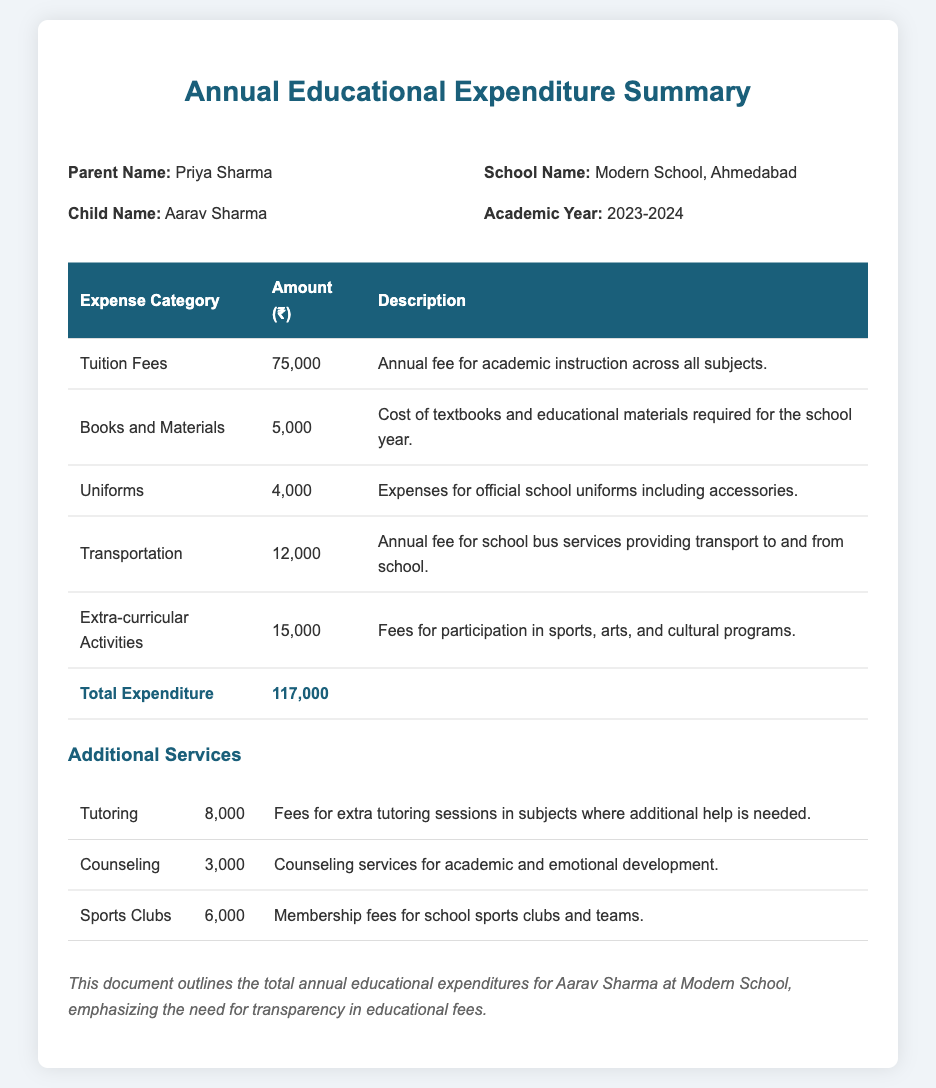What is the total tuition fee? The document specifies that the tuition fee for the academic year is ₹75,000.
Answer: ₹75,000 What is the amount spent on uniforms? The expenditure summary lists the cost for uniforms as ₹4,000.
Answer: ₹4,000 What type of school is Aarav enrolled in? The document indicates that Aarav is enrolled in Modern School, Ahmedabad.
Answer: Modern School What are the total annual educational expenses? The total expenditure is presented in the document as ₹117,000.
Answer: ₹117,000 How much does tutoring cost? The document notes that tutoring fees are ₹8,000.
Answer: ₹8,000 How many categories of expenses are listed in the main table? The document contains six main expense categories.
Answer: Six What is the purpose of the additional services section? The document outlines various services that can support Aarav's education beyond standard fees.
Answer: Support education What is the total fee for extra-curricular activities? The total amount allocated for extra-curricular activities is ₹15,000.
Answer: ₹15,000 What emotional development service is mentioned? The document includes counseling services for academic and emotional development.
Answer: Counseling 